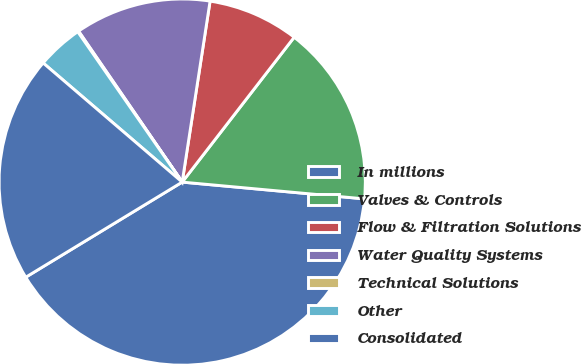Convert chart. <chart><loc_0><loc_0><loc_500><loc_500><pie_chart><fcel>In millions<fcel>Valves & Controls<fcel>Flow & Filtration Solutions<fcel>Water Quality Systems<fcel>Technical Solutions<fcel>Other<fcel>Consolidated<nl><fcel>39.85%<fcel>15.99%<fcel>8.04%<fcel>12.01%<fcel>0.09%<fcel>4.06%<fcel>19.97%<nl></chart> 